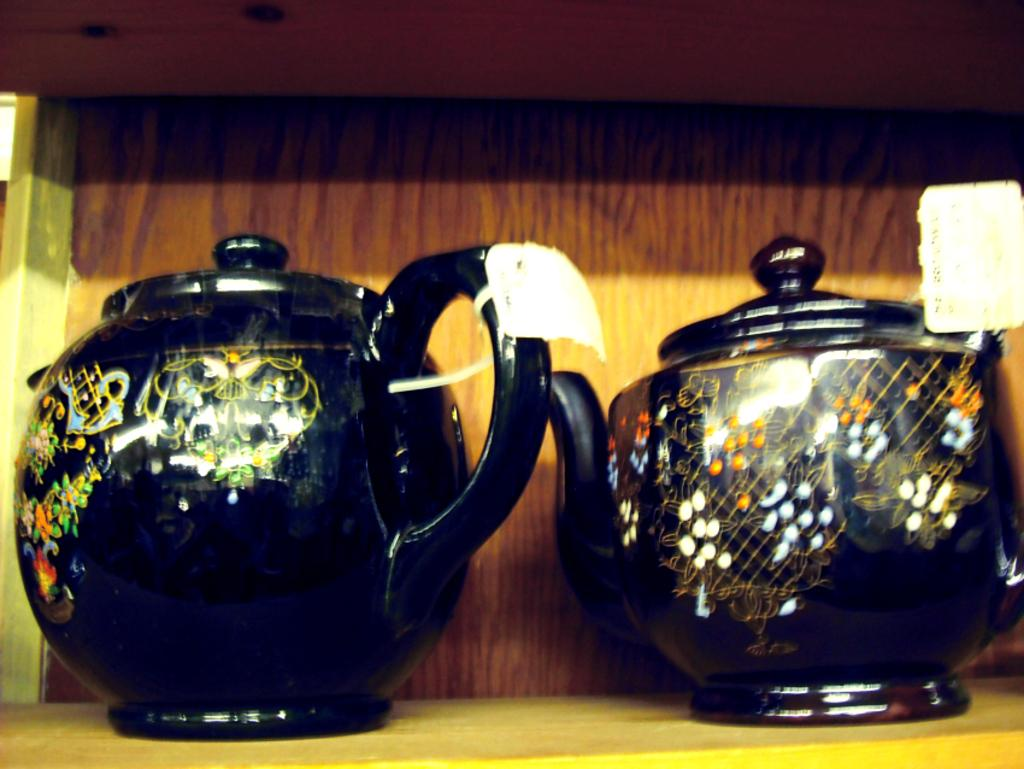What objects are located in the center of the image? There are two pots in the center of the image. What type of material is used for the board in the background? The board in the background is made of wood. Are there any other wooden boards visible in the image? Yes, there are wooden boards at the top and bottom of the image. What type of degree is being awarded to the dirt in the image? There is no dirt or degree present in the image. 